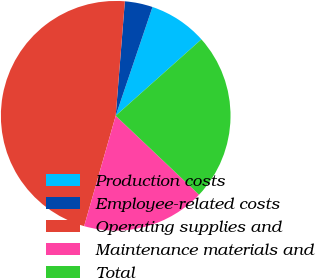<chart> <loc_0><loc_0><loc_500><loc_500><pie_chart><fcel>Production costs<fcel>Employee-related costs<fcel>Operating supplies and<fcel>Maintenance materials and<fcel>Total<nl><fcel>8.22%<fcel>3.92%<fcel>46.84%<fcel>17.36%<fcel>23.66%<nl></chart> 